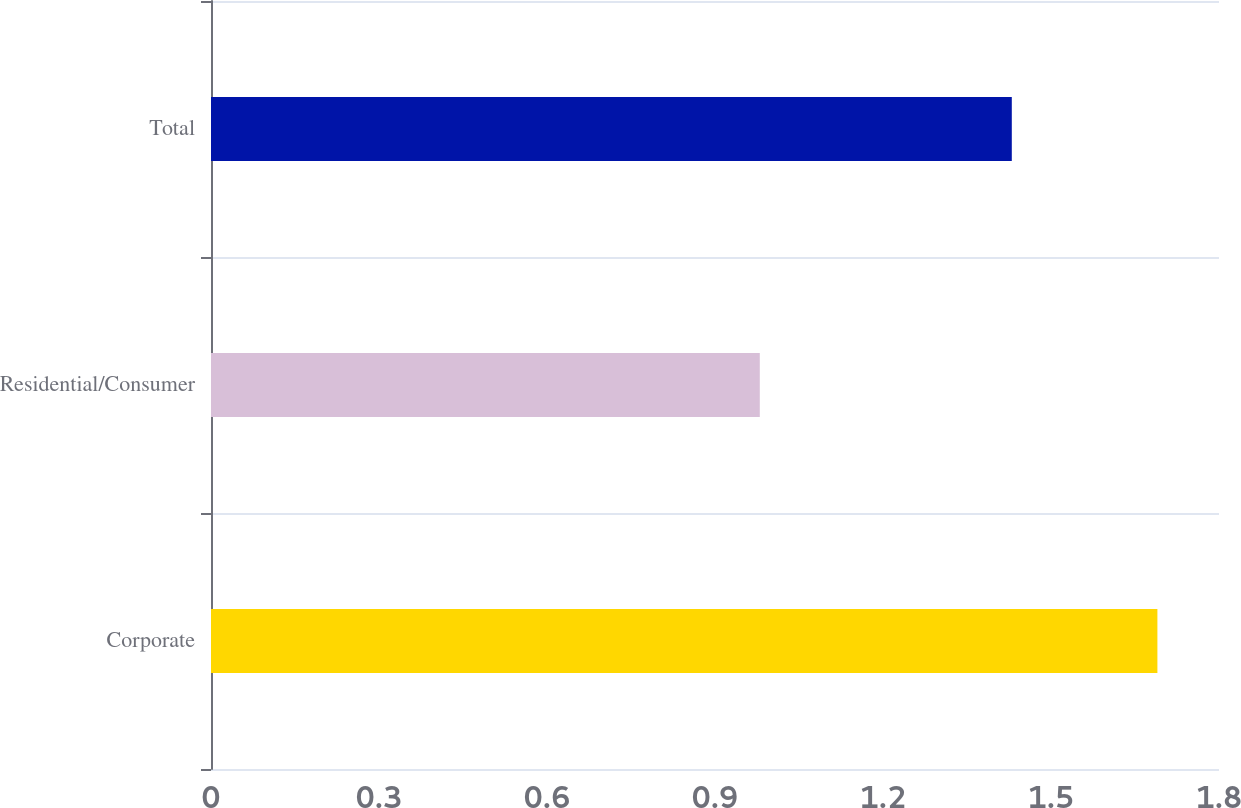Convert chart. <chart><loc_0><loc_0><loc_500><loc_500><bar_chart><fcel>Corporate<fcel>Residential/Consumer<fcel>Total<nl><fcel>1.69<fcel>0.98<fcel>1.43<nl></chart> 